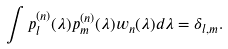<formula> <loc_0><loc_0><loc_500><loc_500>\int p _ { l } ^ { ( n ) } ( \lambda ) p _ { m } ^ { ( n ) } ( \lambda ) w _ { n } ( \lambda ) d \lambda = \delta _ { l , m } .</formula> 